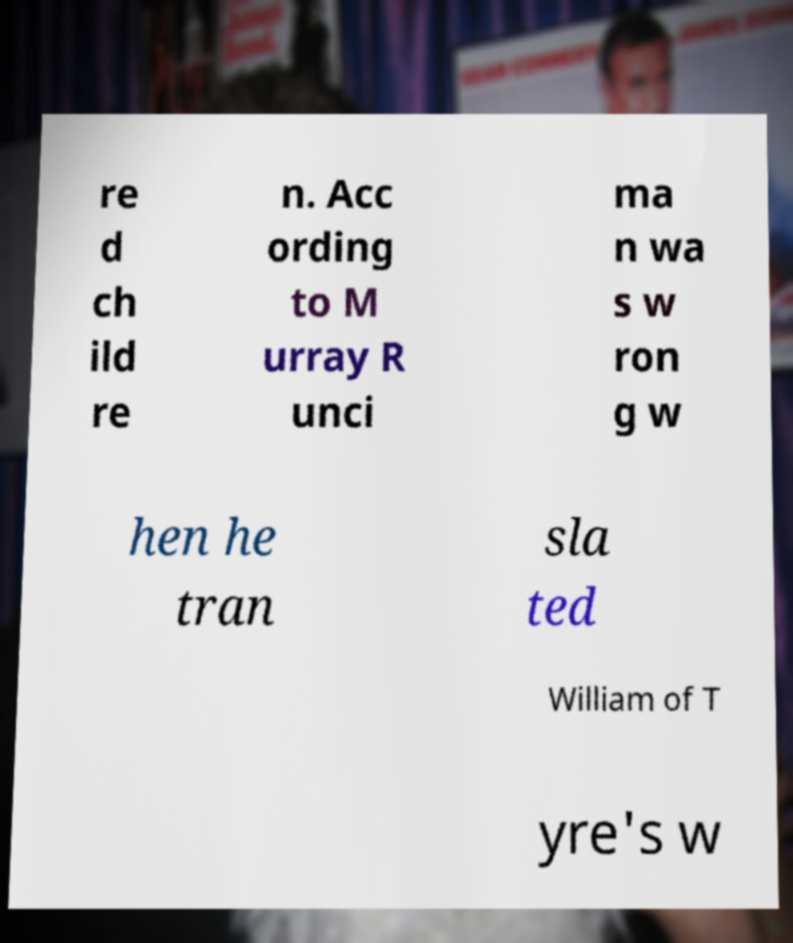Could you extract and type out the text from this image? re d ch ild re n. Acc ording to M urray R unci ma n wa s w ron g w hen he tran sla ted William of T yre's w 